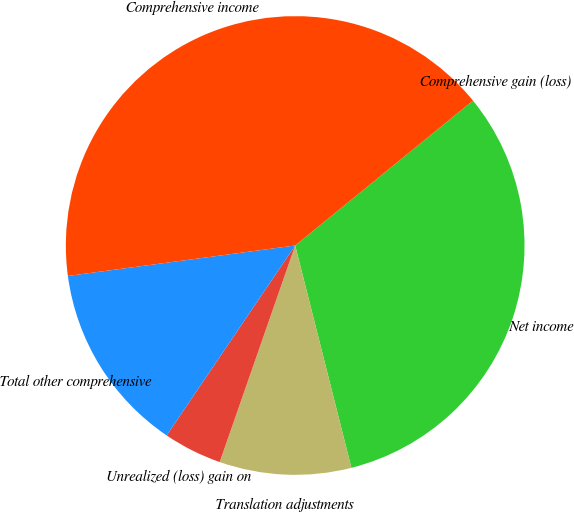<chart> <loc_0><loc_0><loc_500><loc_500><pie_chart><fcel>Net income<fcel>Translation adjustments<fcel>Unrealized (loss) gain on<fcel>Total other comprehensive<fcel>Comprehensive income<fcel>Comprehensive gain (loss)<nl><fcel>31.94%<fcel>9.28%<fcel>4.13%<fcel>13.41%<fcel>41.24%<fcel>0.0%<nl></chart> 